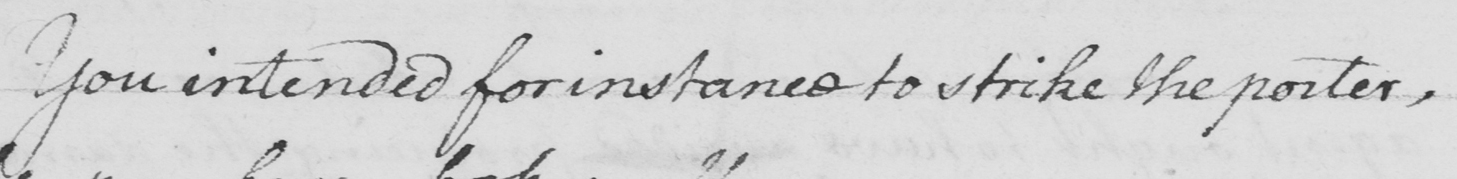Transcribe the text shown in this historical manuscript line. You intended for instance to strike the porter, 